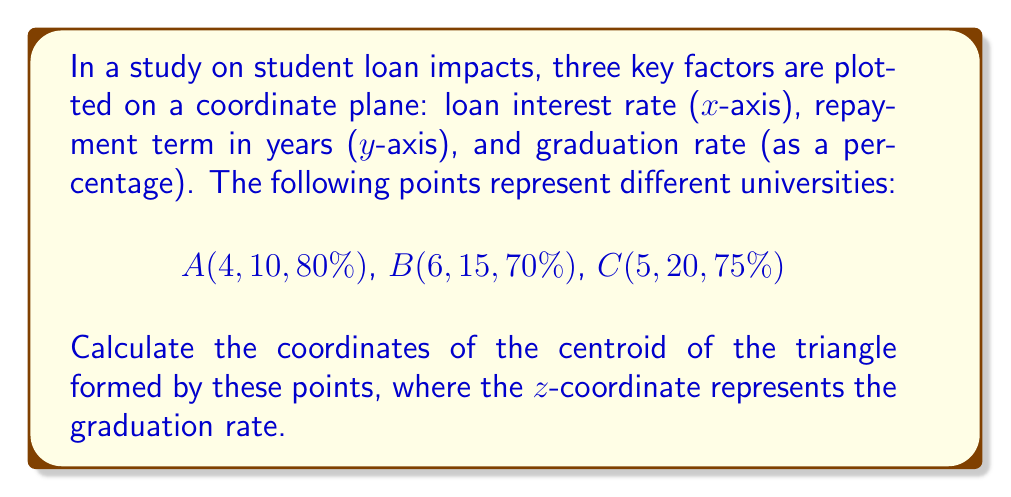Can you solve this math problem? To find the centroid of a triangle, we need to follow these steps:

1. Convert the given points to 3D coordinates:
   A(4, 10, 80)
   B(6, 15, 70)
   C(5, 20, 75)

2. The formula for the centroid (G) of a triangle with vertices (x1, y1, z1), (x2, y2, z2), and (x3, y3, z3) is:

   $$G = (\frac{x1 + x2 + x3}{3}, \frac{y1 + y2 + y3}{3}, \frac{z1 + z2 + z3}{3})$$

3. Substitute the values:
   $$G_x = \frac{4 + 6 + 5}{3} = \frac{15}{3} = 5$$
   $$G_y = \frac{10 + 15 + 20}{3} = \frac{45}{3} = 15$$
   $$G_z = \frac{80 + 70 + 75}{3} = \frac{225}{3} = 75$$

4. Therefore, the centroid G has coordinates (5, 15, 75).

Interpretation:
- The x-coordinate (5) represents the average loan interest rate.
- The y-coordinate (15) represents the average repayment term in years.
- The z-coordinate (75) represents the average graduation rate as a percentage.
Answer: (5, 15, 75) 